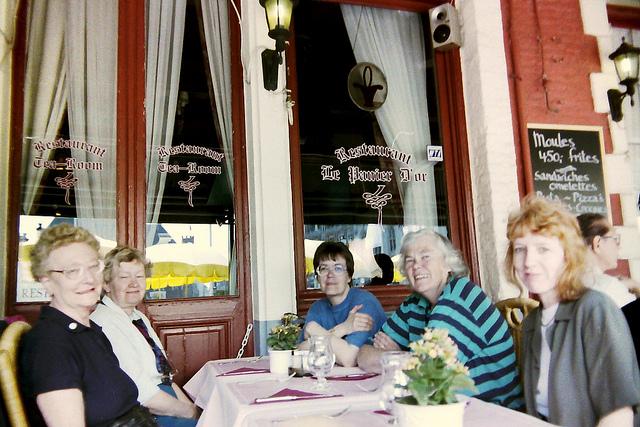How many people are at the table?
Write a very short answer. 5. Are these people eating indoors?
Quick response, please. No. Is anyone wearing glasses?
Write a very short answer. Yes. 